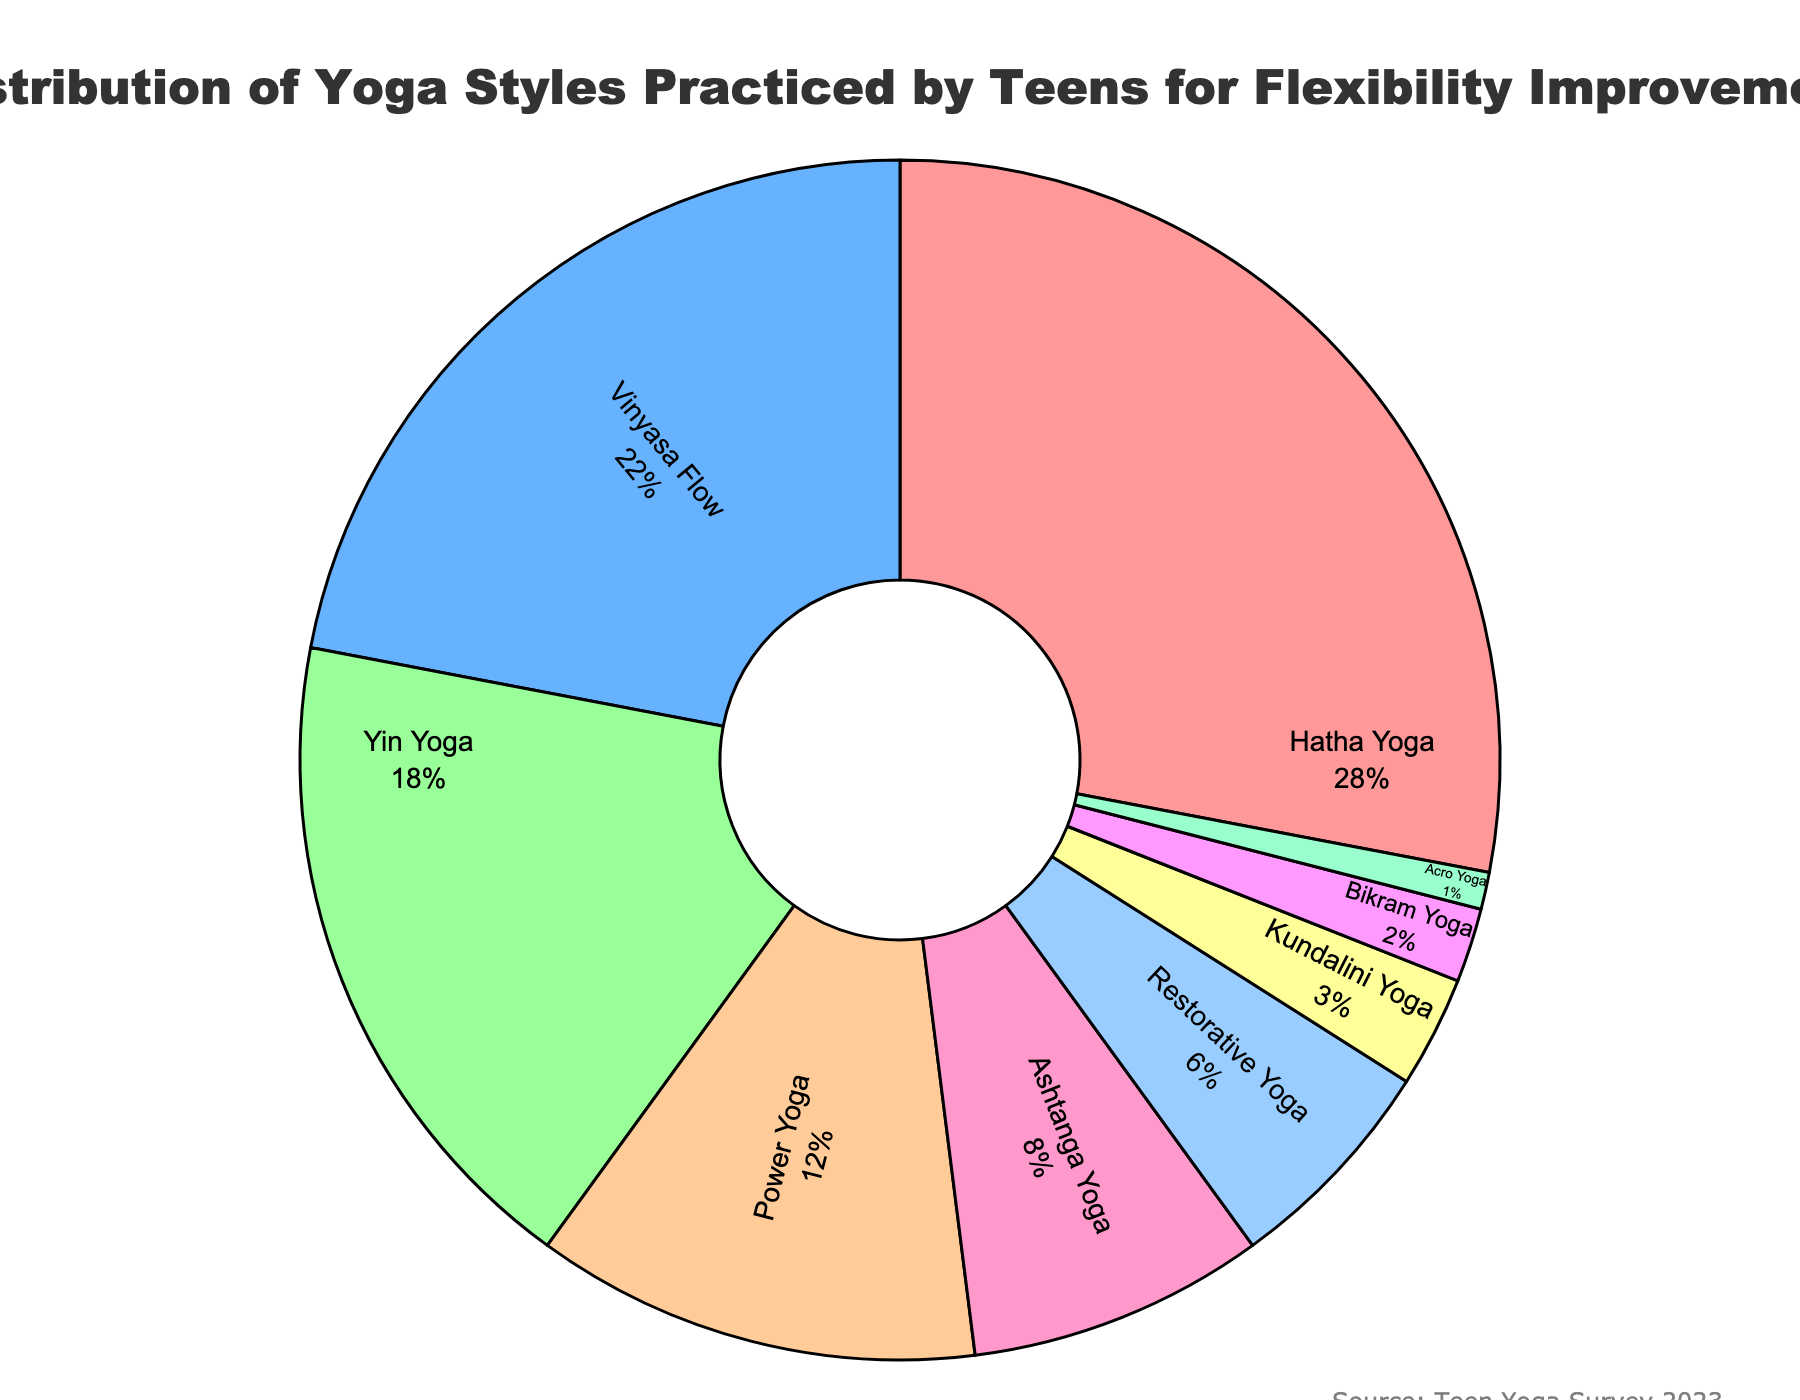What percentage of teens practice Hatha Yoga? Look at the slice labeled "Hatha Yoga" in the pie chart; it shows 28%.
Answer: 28% Which yoga style is practiced by the smallest percentage of teens? Find the smallest slice in the chart, which corresponds to Acro Yoga with 1%.
Answer: Acro Yoga How many yoga styles are practiced by less than 10% of teens? Identify all the slices in the chart less than 10%: Ashtanga Yoga (8%), Restorative Yoga (6%), Kundalini Yoga (3%), Bikram Yoga (2%), and Acro Yoga (1%). There are 5 styles.
Answer: 5 What is the combined percentage of teens practicing Yin Yoga and Power Yoga? Find the slices for Yin Yoga (18%) and Power Yoga (12%), then add them: 18% + 12% = 30%.
Answer: 30% Which yoga style is more popular among teens, Vinyasa Flow or Ashtanga Yoga? Compare the percentages of the two styles: Vinyasa Flow (22%) is greater than Ashtanga Yoga (8%).
Answer: Vinyasa Flow How much more popular is Hatha Yoga compared to Power Yoga? Subtract the percentage of Power Yoga (12%) from Hatha Yoga (28%): 28% - 12% = 16%.
Answer: 16% Which slices are represented in shades of green? Inspect the colors in the pie chart. The green shades correspond to Yoga Styles Yin Yoga (18%) and Acro Yoga (1%).
Answer: Yin Yoga, Acro Yoga What is the difference in percentage between Restorative Yoga and Kundalini Yoga? Subtract the percentage of Kundalini Yoga (3%) from Restorative Yoga (6%): 6% - 3% = 3%.
Answer: 3% What is the second most popular yoga style practiced by teens? Look at the second largest slice in the chart, which corresponds to Vinyasa Flow with 22%.
Answer: Vinyasa Flow 